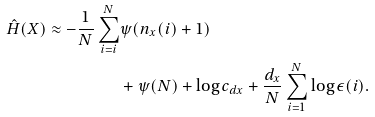Convert formula to latex. <formula><loc_0><loc_0><loc_500><loc_500>\hat { H } ( X ) \approx - \frac { 1 } { N } \sum _ { i = i } ^ { N } & \psi ( n _ { x } ( i ) + 1 ) \\ & + \psi ( N ) + \log c _ { d x } + \frac { d _ { x } } { N } \sum _ { i = 1 } ^ { N } \log \epsilon ( i ) .</formula> 